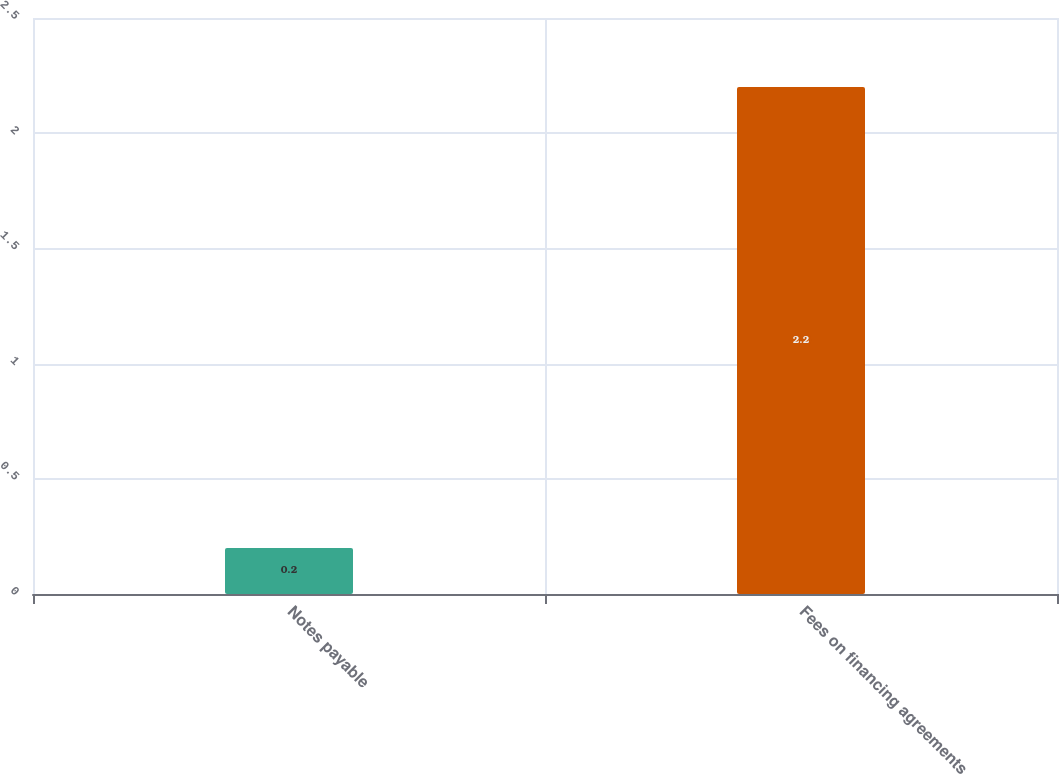Convert chart. <chart><loc_0><loc_0><loc_500><loc_500><bar_chart><fcel>Notes payable<fcel>Fees on financing agreements<nl><fcel>0.2<fcel>2.2<nl></chart> 